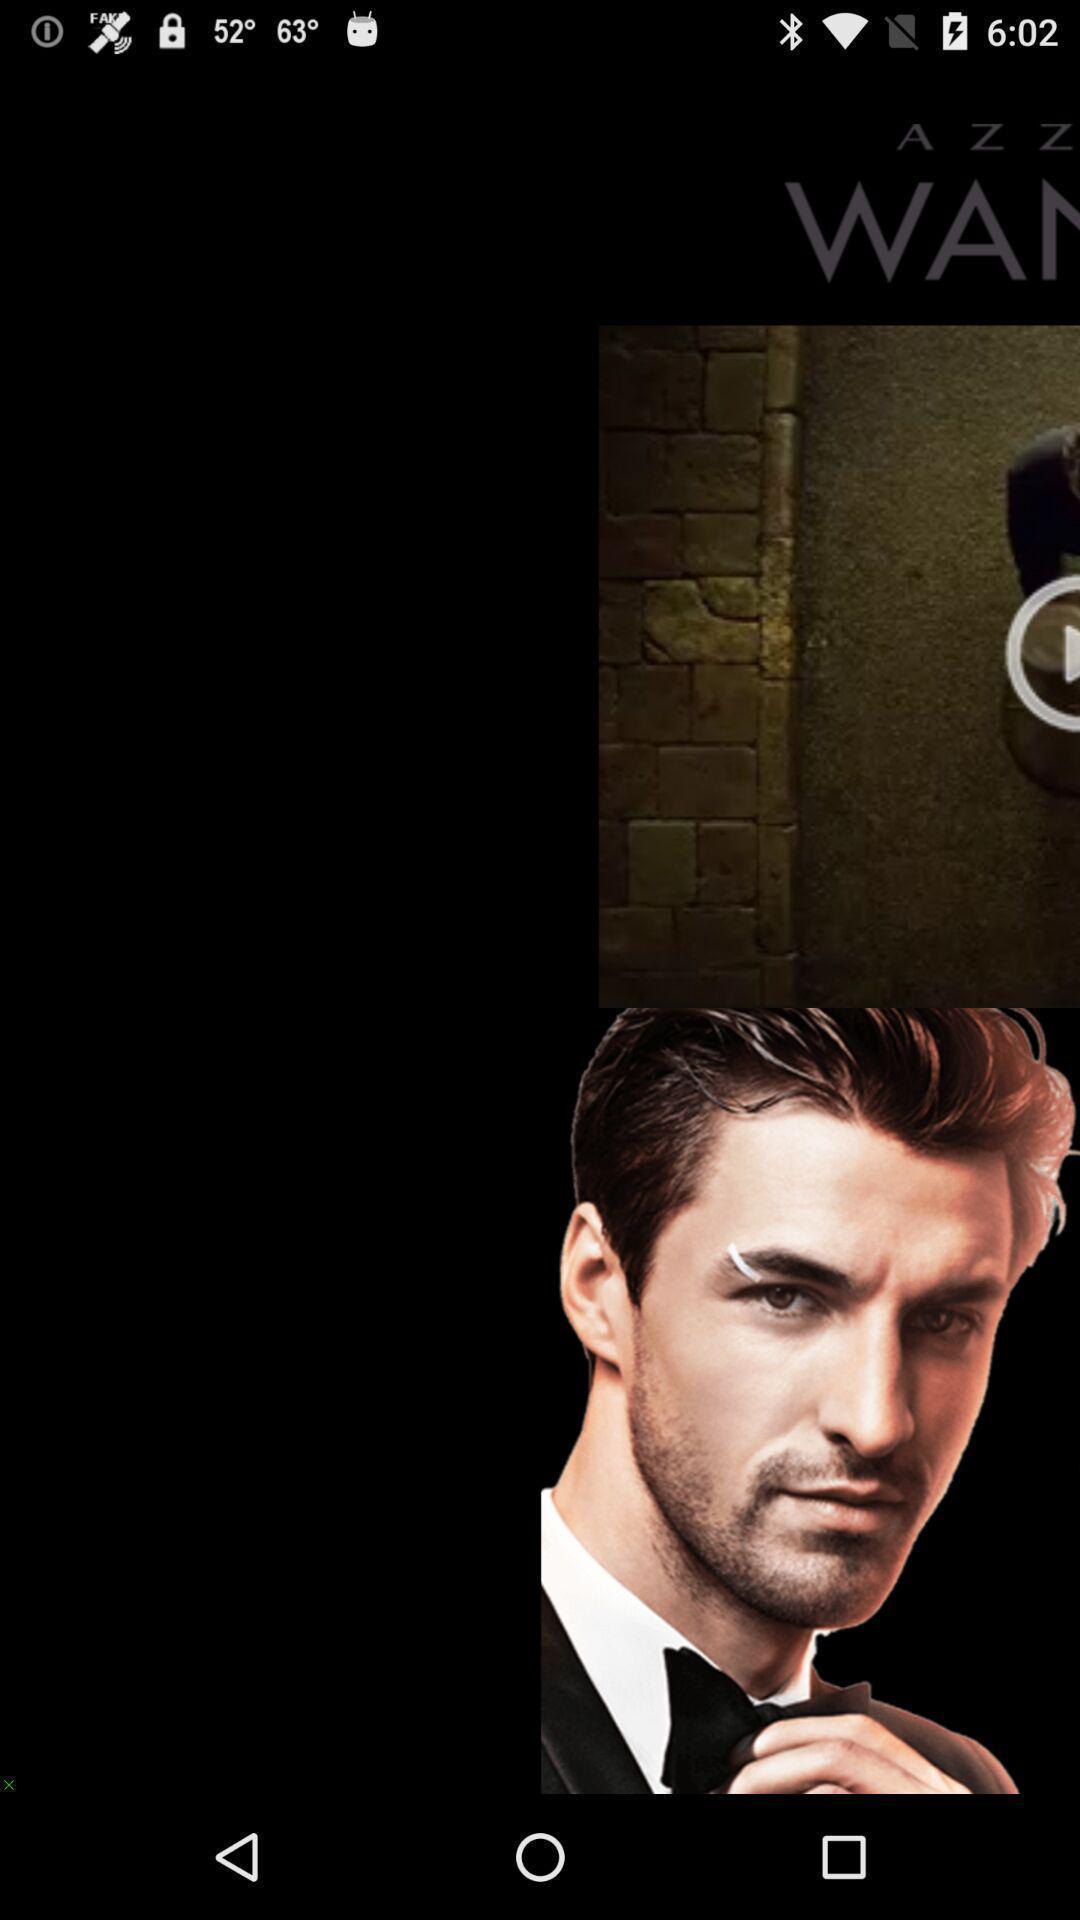What details can you identify in this image? Screen displaying an image in a fitness application. 